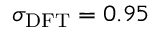Convert formula to latex. <formula><loc_0><loc_0><loc_500><loc_500>\sigma _ { D F T } = 0 . 9 5</formula> 